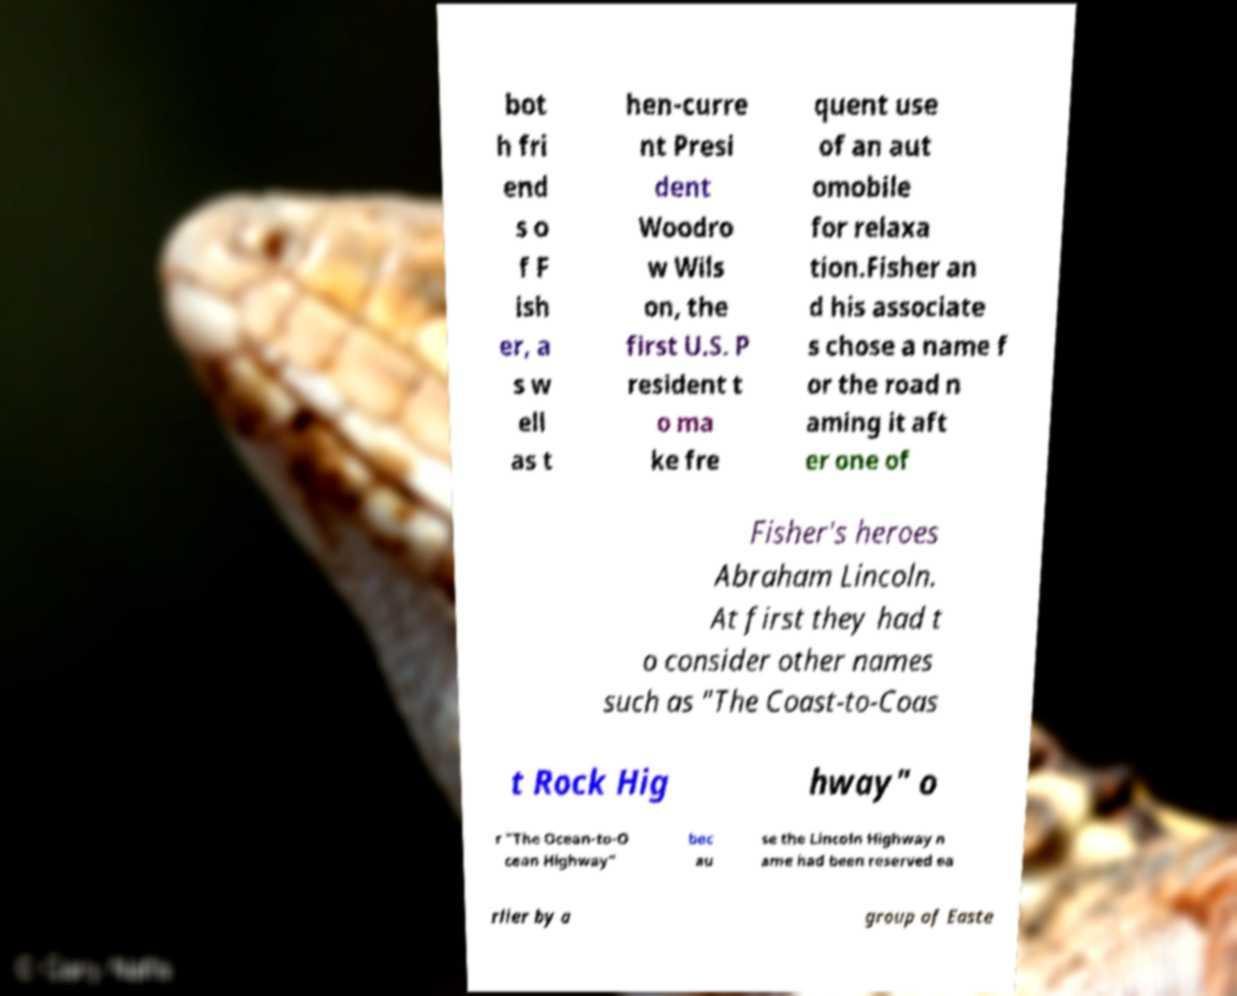There's text embedded in this image that I need extracted. Can you transcribe it verbatim? bot h fri end s o f F ish er, a s w ell as t hen-curre nt Presi dent Woodro w Wils on, the first U.S. P resident t o ma ke fre quent use of an aut omobile for relaxa tion.Fisher an d his associate s chose a name f or the road n aming it aft er one of Fisher's heroes Abraham Lincoln. At first they had t o consider other names such as "The Coast-to-Coas t Rock Hig hway" o r "The Ocean-to-O cean Highway" bec au se the Lincoln Highway n ame had been reserved ea rlier by a group of Easte 